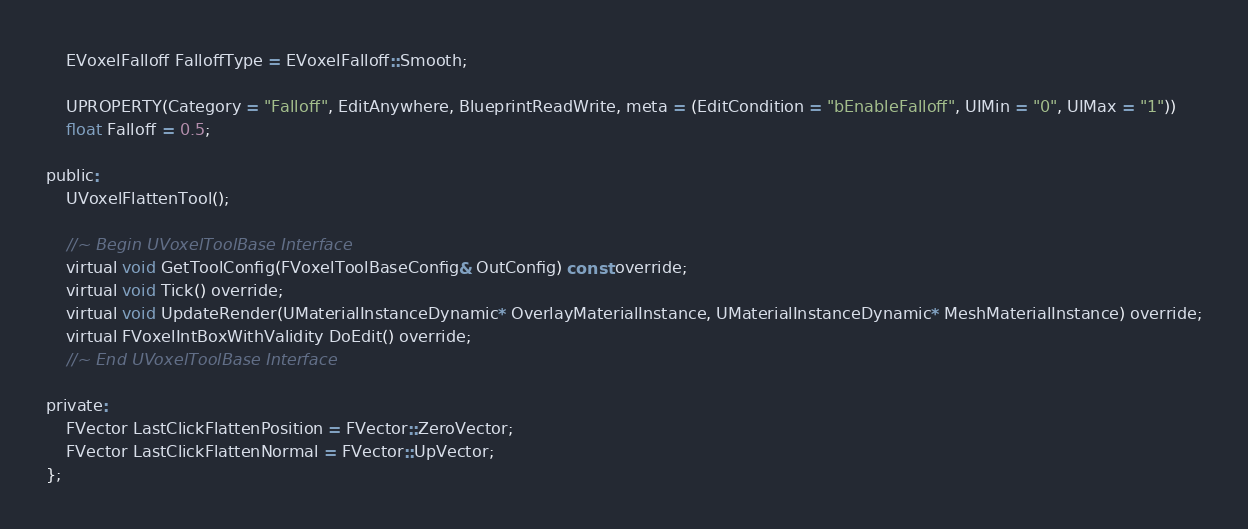<code> <loc_0><loc_0><loc_500><loc_500><_C_>	EVoxelFalloff FalloffType = EVoxelFalloff::Smooth;

	UPROPERTY(Category = "Falloff", EditAnywhere, BlueprintReadWrite, meta = (EditCondition = "bEnableFalloff", UIMin = "0", UIMax = "1"))
	float Falloff = 0.5;

public:
	UVoxelFlattenTool();
	
	//~ Begin UVoxelToolBase Interface
	virtual void GetToolConfig(FVoxelToolBaseConfig& OutConfig) const override;
	virtual void Tick() override;
	virtual void UpdateRender(UMaterialInstanceDynamic* OverlayMaterialInstance, UMaterialInstanceDynamic* MeshMaterialInstance) override;
	virtual FVoxelIntBoxWithValidity DoEdit() override;
	//~ End UVoxelToolBase Interface

private:
	FVector LastClickFlattenPosition = FVector::ZeroVector;
	FVector LastClickFlattenNormal = FVector::UpVector;
};</code> 